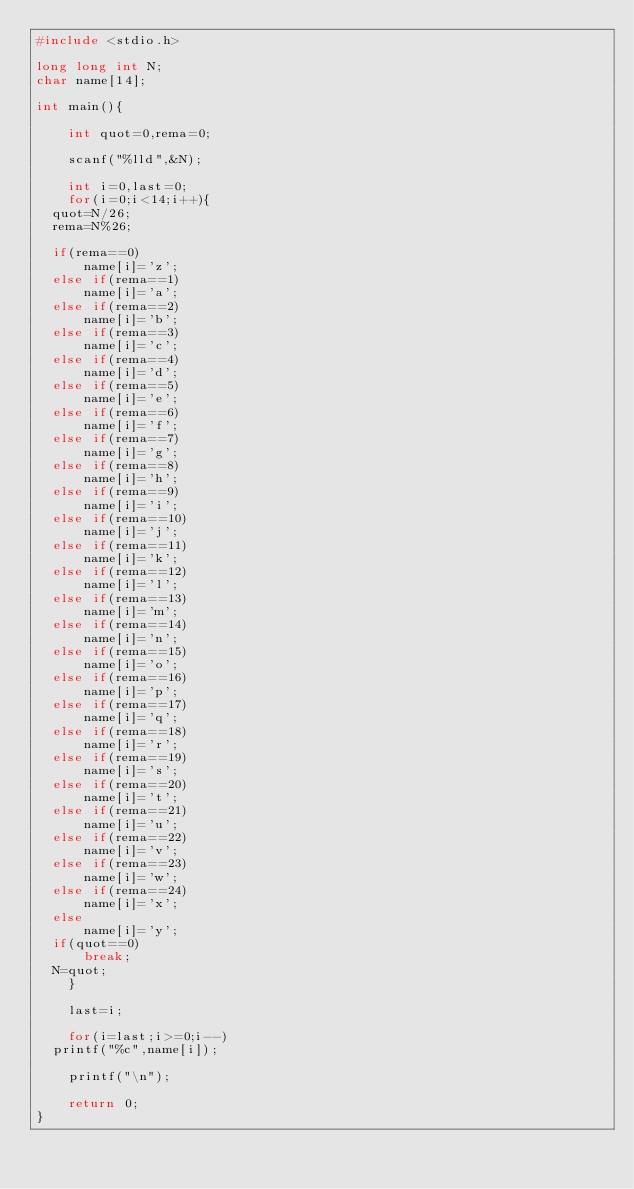<code> <loc_0><loc_0><loc_500><loc_500><_C_>#include <stdio.h>

long long int N;
char name[14];

int main(){
    
    int quot=0,rema=0;

    scanf("%lld",&N);

    int i=0,last=0;
    for(i=0;i<14;i++){
	quot=N/26;
	rema=N%26;

	if(rema==0)
	    name[i]='z';
	else if(rema==1)
	    name[i]='a';
	else if(rema==2)
	    name[i]='b';
	else if(rema==3)
	    name[i]='c';
	else if(rema==4)
	    name[i]='d';
	else if(rema==5)
	    name[i]='e';
	else if(rema==6)
	    name[i]='f';
	else if(rema==7)
	    name[i]='g';
	else if(rema==8)
	    name[i]='h';
	else if(rema==9)
	    name[i]='i';
	else if(rema==10)
	    name[i]='j';
	else if(rema==11)
	    name[i]='k';
	else if(rema==12)
	    name[i]='l';
	else if(rema==13)
	    name[i]='m';
	else if(rema==14)
	    name[i]='n';
	else if(rema==15)
	    name[i]='o';
	else if(rema==16)
	    name[i]='p';
	else if(rema==17)
	    name[i]='q';
	else if(rema==18)
	    name[i]='r';
	else if(rema==19)
	    name[i]='s';
	else if(rema==20)
	    name[i]='t';
	else if(rema==21)
	    name[i]='u';
	else if(rema==22)
	    name[i]='v';
	else if(rema==23)
	    name[i]='w';
	else if(rema==24)
	    name[i]='x';
	else
	    name[i]='y';
	if(quot==0)
	    break;
	N=quot;
    }

    last=i;

    for(i=last;i>=0;i--)
	printf("%c",name[i]);

    printf("\n");

    return 0;
}

</code> 